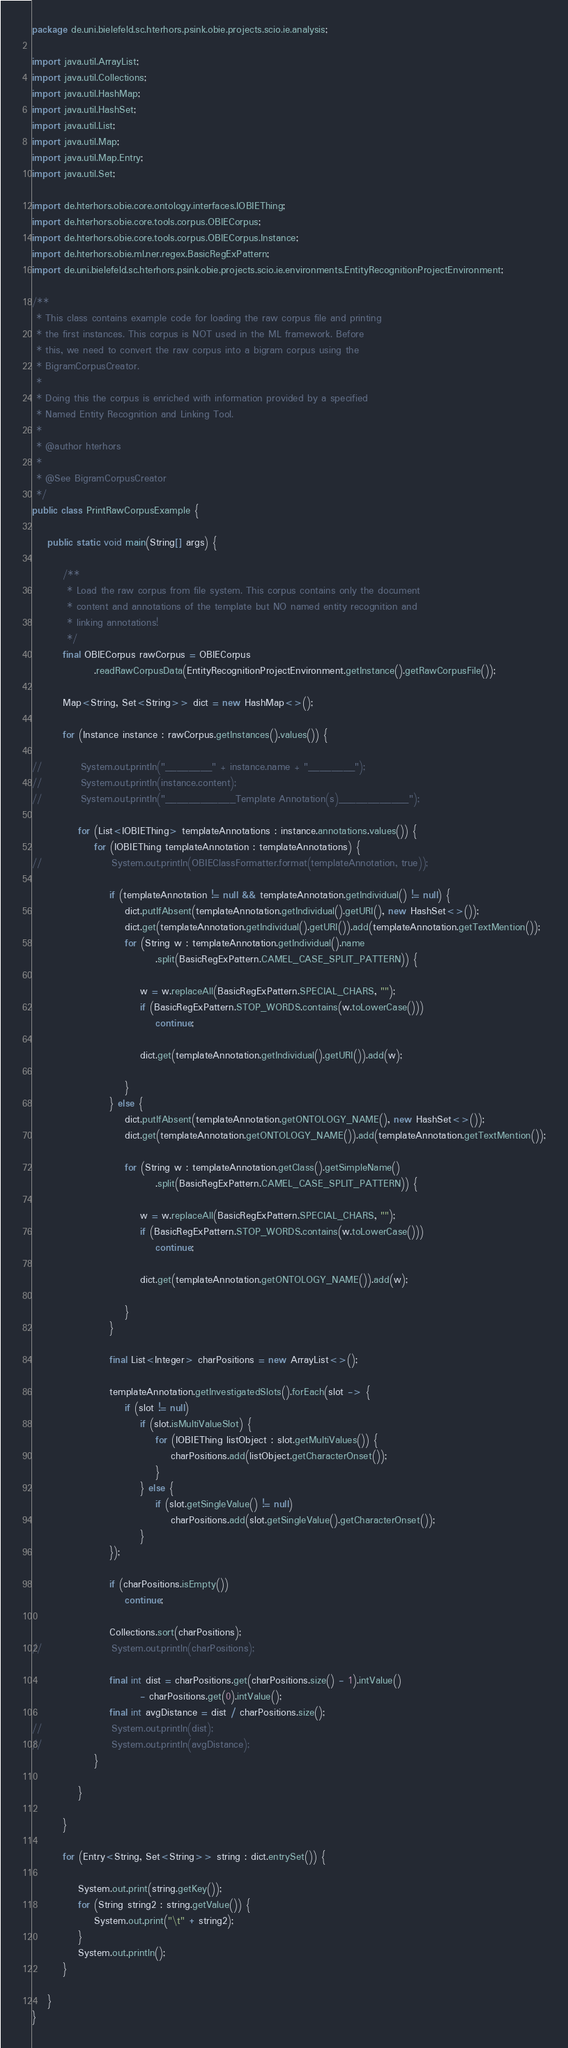<code> <loc_0><loc_0><loc_500><loc_500><_Java_>package de.uni.bielefeld.sc.hterhors.psink.obie.projects.scio.ie.analysis;

import java.util.ArrayList;
import java.util.Collections;
import java.util.HashMap;
import java.util.HashSet;
import java.util.List;
import java.util.Map;
import java.util.Map.Entry;
import java.util.Set;

import de.hterhors.obie.core.ontology.interfaces.IOBIEThing;
import de.hterhors.obie.core.tools.corpus.OBIECorpus;
import de.hterhors.obie.core.tools.corpus.OBIECorpus.Instance;
import de.hterhors.obie.ml.ner.regex.BasicRegExPattern;
import de.uni.bielefeld.sc.hterhors.psink.obie.projects.scio.ie.environments.EntityRecognitionProjectEnvironment;

/**
 * This class contains example code for loading the raw corpus file and printing
 * the first instances. This corpus is NOT used in the ML framework. Before
 * this, we need to convert the raw corpus into a bigram corpus using the
 * BigramCorpusCreator.
 * 
 * Doing this the corpus is enriched with information provided by a specified
 * Named Entity Recognition and Linking Tool.
 * 
 * @author hterhors
 *
 * @See BigramCorpusCreator
 */
public class PrintRawCorpusExample {

	public static void main(String[] args) {

		/**
		 * Load the raw corpus from file system. This corpus contains only the document
		 * content and annotations of the template but NO named entity recognition and
		 * linking annotations!
		 */
		final OBIECorpus rawCorpus = OBIECorpus
				.readRawCorpusData(EntityRecognitionProjectEnvironment.getInstance().getRawCorpusFile());

		Map<String, Set<String>> dict = new HashMap<>();

		for (Instance instance : rawCorpus.getInstances().values()) {

//			System.out.println("________" + instance.name + "________");
//			System.out.println(instance.content);
//			System.out.println("____________Template Annotation(s)____________");

			for (List<IOBIEThing> templateAnnotations : instance.annotations.values()) {
				for (IOBIEThing templateAnnotation : templateAnnotations) {
//					System.out.println(OBIEClassFormatter.format(templateAnnotation, true));

					if (templateAnnotation != null && templateAnnotation.getIndividual() != null) {
						dict.putIfAbsent(templateAnnotation.getIndividual().getURI(), new HashSet<>());
						dict.get(templateAnnotation.getIndividual().getURI()).add(templateAnnotation.getTextMention());
						for (String w : templateAnnotation.getIndividual().name
								.split(BasicRegExPattern.CAMEL_CASE_SPLIT_PATTERN)) {

							w = w.replaceAll(BasicRegExPattern.SPECIAL_CHARS, "");
							if (BasicRegExPattern.STOP_WORDS.contains(w.toLowerCase()))
								continue;

							dict.get(templateAnnotation.getIndividual().getURI()).add(w);

						}
					} else {
						dict.putIfAbsent(templateAnnotation.getONTOLOGY_NAME(), new HashSet<>());
						dict.get(templateAnnotation.getONTOLOGY_NAME()).add(templateAnnotation.getTextMention());

						for (String w : templateAnnotation.getClass().getSimpleName()
								.split(BasicRegExPattern.CAMEL_CASE_SPLIT_PATTERN)) {

							w = w.replaceAll(BasicRegExPattern.SPECIAL_CHARS, "");
							if (BasicRegExPattern.STOP_WORDS.contains(w.toLowerCase()))
								continue;

							dict.get(templateAnnotation.getONTOLOGY_NAME()).add(w);

						}
					}

					final List<Integer> charPositions = new ArrayList<>();

					templateAnnotation.getInvestigatedSlots().forEach(slot -> {
						if (slot != null)
							if (slot.isMultiValueSlot) {
								for (IOBIEThing listObject : slot.getMultiValues()) {
									charPositions.add(listObject.getCharacterOnset());
								}
							} else {
								if (slot.getSingleValue() != null)
									charPositions.add(slot.getSingleValue().getCharacterOnset());
							}
					});

					if (charPositions.isEmpty())
						continue;

					Collections.sort(charPositions);
//					System.out.println(charPositions);

					final int dist = charPositions.get(charPositions.size() - 1).intValue()
							- charPositions.get(0).intValue();
					final int avgDistance = dist / charPositions.size();
//					System.out.println(dist);
//					System.out.println(avgDistance);
				}

			}

		}

		for (Entry<String, Set<String>> string : dict.entrySet()) {

			System.out.print(string.getKey());
			for (String string2 : string.getValue()) {
				System.out.print("\t" + string2);
			}
			System.out.println();
		}

	}
}
</code> 